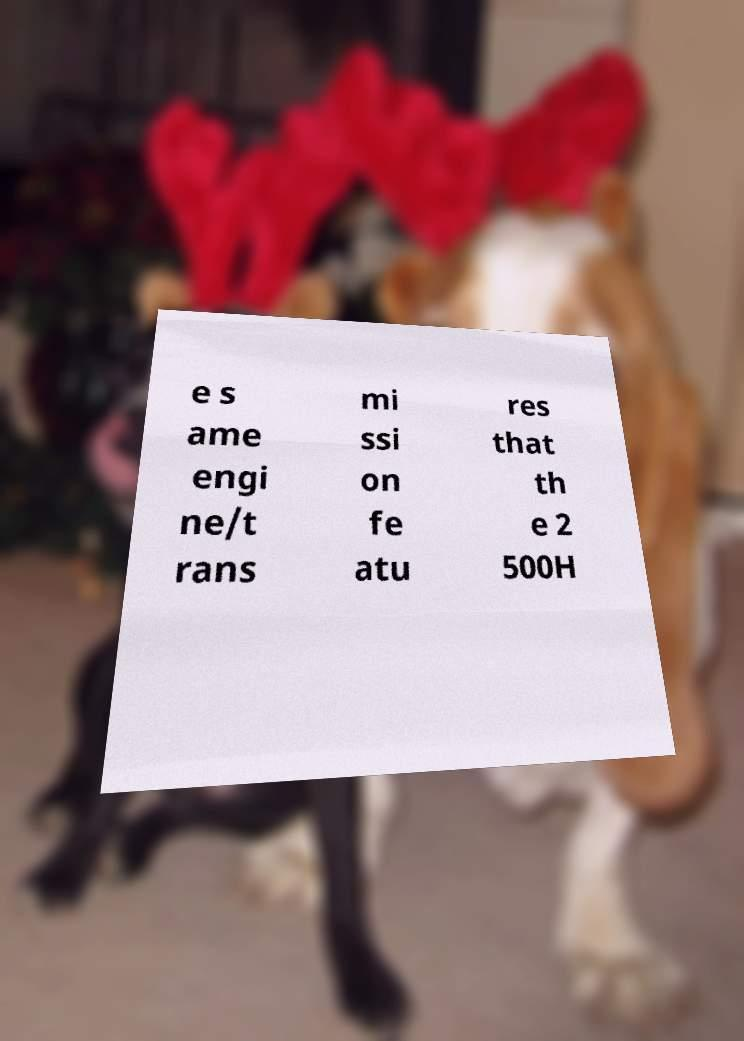What messages or text are displayed in this image? I need them in a readable, typed format. e s ame engi ne/t rans mi ssi on fe atu res that th e 2 500H 